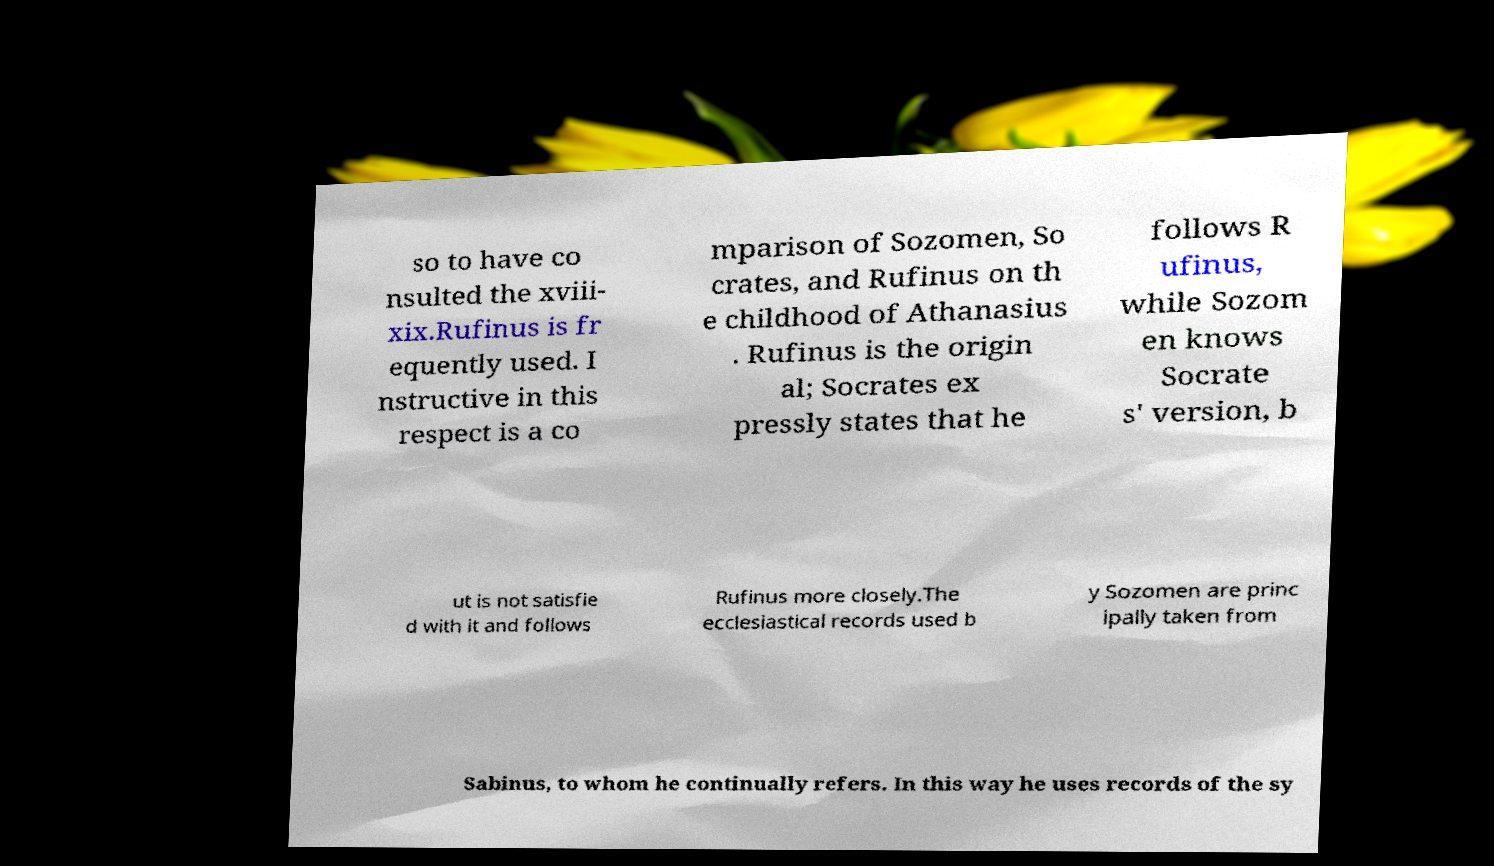Could you assist in decoding the text presented in this image and type it out clearly? so to have co nsulted the xviii- xix.Rufinus is fr equently used. I nstructive in this respect is a co mparison of Sozomen, So crates, and Rufinus on th e childhood of Athanasius . Rufinus is the origin al; Socrates ex pressly states that he follows R ufinus, while Sozom en knows Socrate s' version, b ut is not satisfie d with it and follows Rufinus more closely.The ecclesiastical records used b y Sozomen are princ ipally taken from Sabinus, to whom he continually refers. In this way he uses records of the sy 